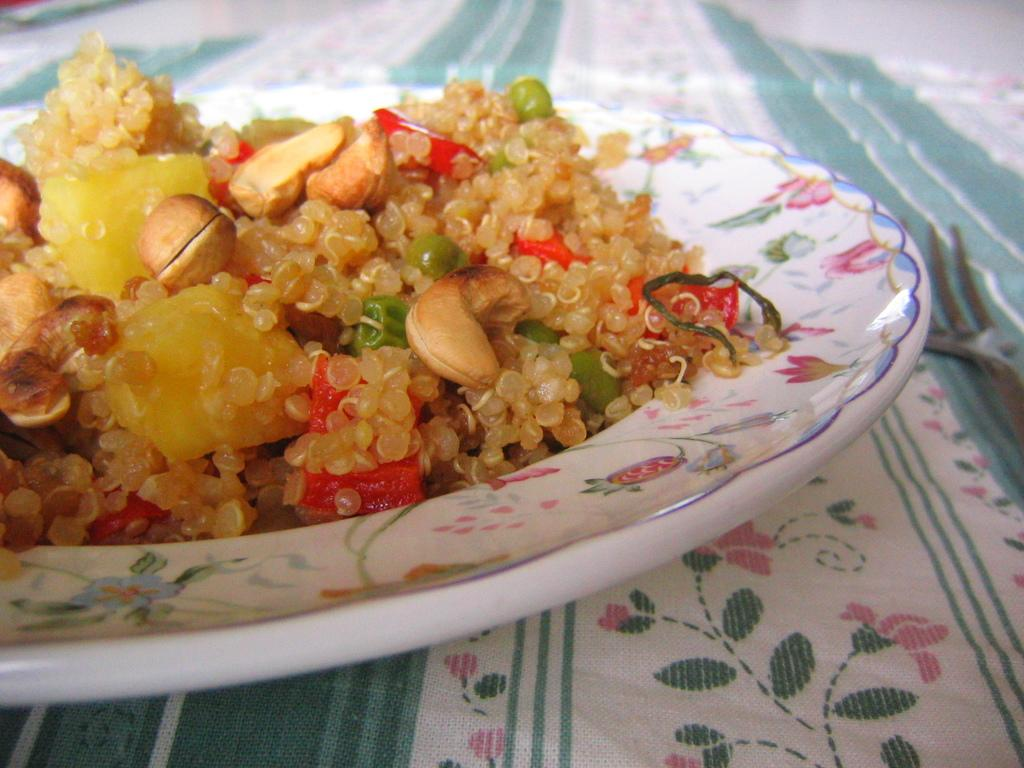What is on the plate in the image? There is food on the plate in the image. What is located at the bottom of the image? There is a cloth at the bottom of the image. What utensil is placed near the plate? There is a fork on the right side of the plate. What type of honey is being served by the police officer in the image? There is no police officer or honey present in the image. Can you describe the body language of the person eating the food in the image? There is no person visible in the image, only a plate with food, a fork, and a cloth. 